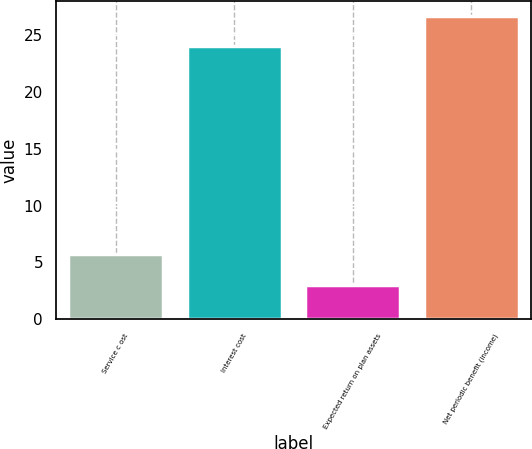<chart> <loc_0><loc_0><loc_500><loc_500><bar_chart><fcel>Service c ost<fcel>Interest cost<fcel>Expected return on plan assets<fcel>Net periodic benefit (income)<nl><fcel>5.7<fcel>24<fcel>3<fcel>26.7<nl></chart> 